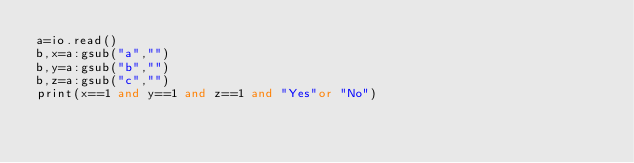Convert code to text. <code><loc_0><loc_0><loc_500><loc_500><_Lua_>a=io.read()
b,x=a:gsub("a","")
b,y=a:gsub("b","")
b,z=a:gsub("c","")
print(x==1 and y==1 and z==1 and "Yes"or "No")</code> 